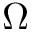Convert formula to latex. <formula><loc_0><loc_0><loc_500><loc_500>\Omega</formula> 